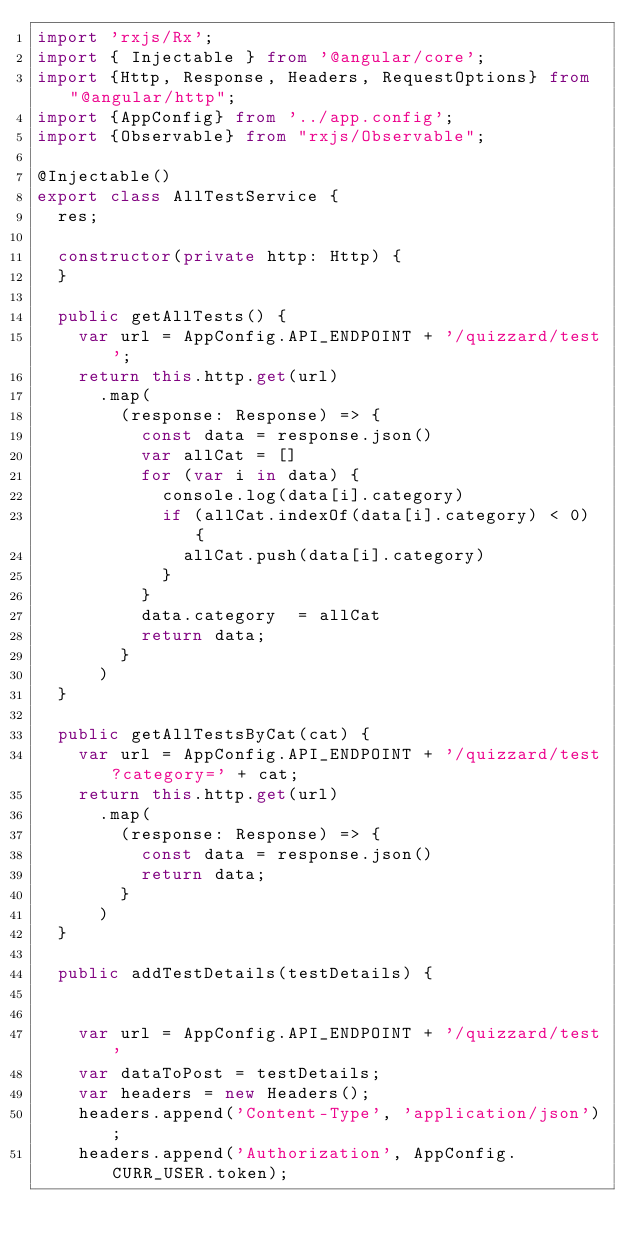Convert code to text. <code><loc_0><loc_0><loc_500><loc_500><_TypeScript_>import 'rxjs/Rx';
import { Injectable } from '@angular/core';
import {Http, Response, Headers, RequestOptions} from "@angular/http";
import {AppConfig} from '../app.config';
import {Observable} from "rxjs/Observable";

@Injectable()
export class AllTestService {
  res;

  constructor(private http: Http) {
  }

  public getAllTests() {
    var url = AppConfig.API_ENDPOINT + '/quizzard/test';
    return this.http.get(url)
      .map(
        (response: Response) => {
          const data = response.json()
          var allCat = []
          for (var i in data) {
            console.log(data[i].category)
            if (allCat.indexOf(data[i].category) < 0) {
              allCat.push(data[i].category)
            }
          }
          data.category  = allCat
          return data;
        }
      )
  }

  public getAllTestsByCat(cat) {
    var url = AppConfig.API_ENDPOINT + '/quizzard/test?category=' + cat;
    return this.http.get(url)
      .map(
        (response: Response) => {
          const data = response.json()
          return data;
        }
      )
  }

  public addTestDetails(testDetails) {


    var url = AppConfig.API_ENDPOINT + '/quizzard/test'
    var dataToPost = testDetails;
    var headers = new Headers();
    headers.append('Content-Type', 'application/json');
    headers.append('Authorization', AppConfig.CURR_USER.token);</code> 